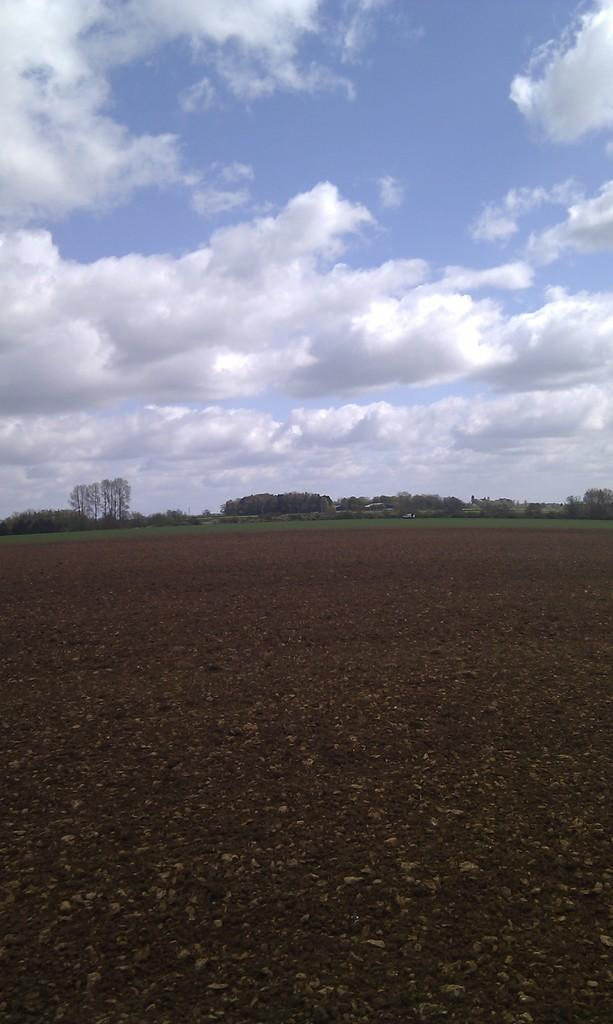What type of vegetation can be seen in the image? There are trees in the image. What part of the natural environment is visible at the bottom of the image? The ground is visible at the bottom of the image. What can be seen in the sky at the top of the image? There are clouds in the sky at the top of the image. Who is the owner of the light in the image? There is no light present in the image, so it is not possible to determine an owner. How does respect manifest itself in the image? There is no indication of respect or any related concept in the image. 